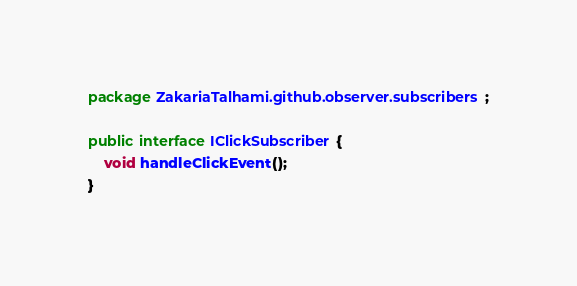<code> <loc_0><loc_0><loc_500><loc_500><_Java_>package ZakariaTalhami.github.observer.subscribers;

public interface IClickSubscriber {
    void handleClickEvent();
}
</code> 